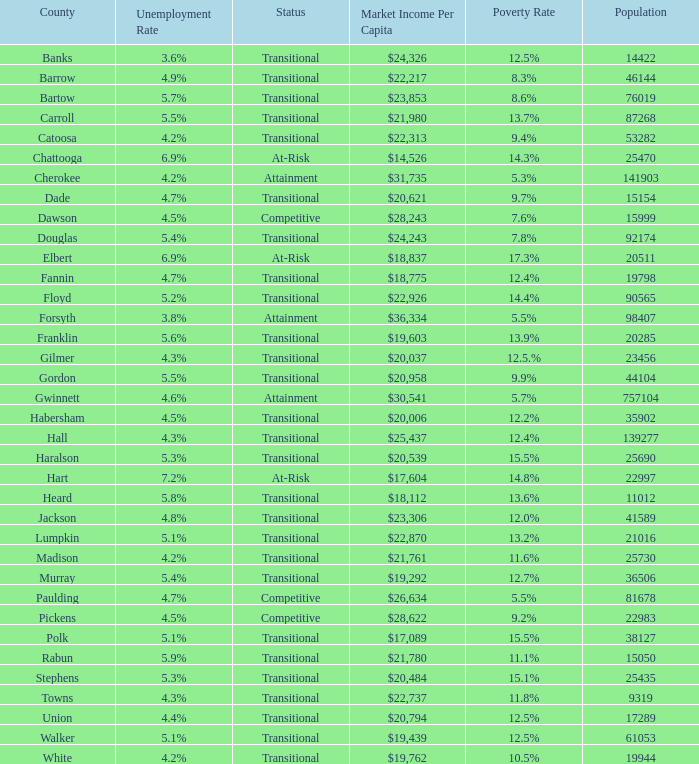Which county had a 3.6% unemployment rate? Banks. 